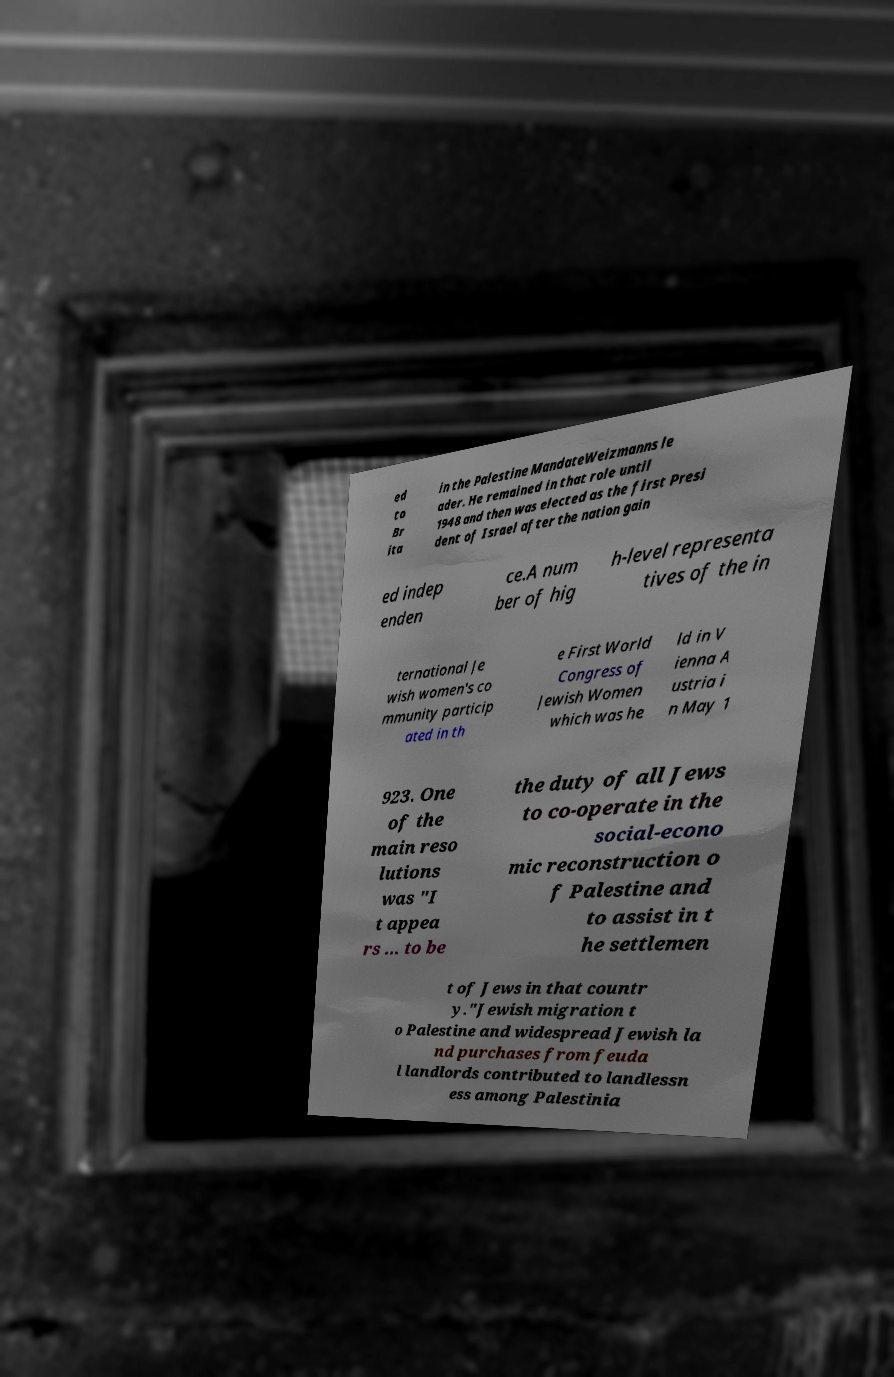Can you read and provide the text displayed in the image?This photo seems to have some interesting text. Can you extract and type it out for me? ed to Br ita in the Palestine MandateWeizmanns le ader. He remained in that role until 1948 and then was elected as the first Presi dent of Israel after the nation gain ed indep enden ce.A num ber of hig h-level representa tives of the in ternational Je wish women's co mmunity particip ated in th e First World Congress of Jewish Women which was he ld in V ienna A ustria i n May 1 923. One of the main reso lutions was "I t appea rs ... to be the duty of all Jews to co-operate in the social-econo mic reconstruction o f Palestine and to assist in t he settlemen t of Jews in that countr y."Jewish migration t o Palestine and widespread Jewish la nd purchases from feuda l landlords contributed to landlessn ess among Palestinia 